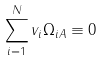Convert formula to latex. <formula><loc_0><loc_0><loc_500><loc_500>\sum _ { i = 1 } ^ { N } v _ { i } \Omega _ { i A } \equiv 0</formula> 